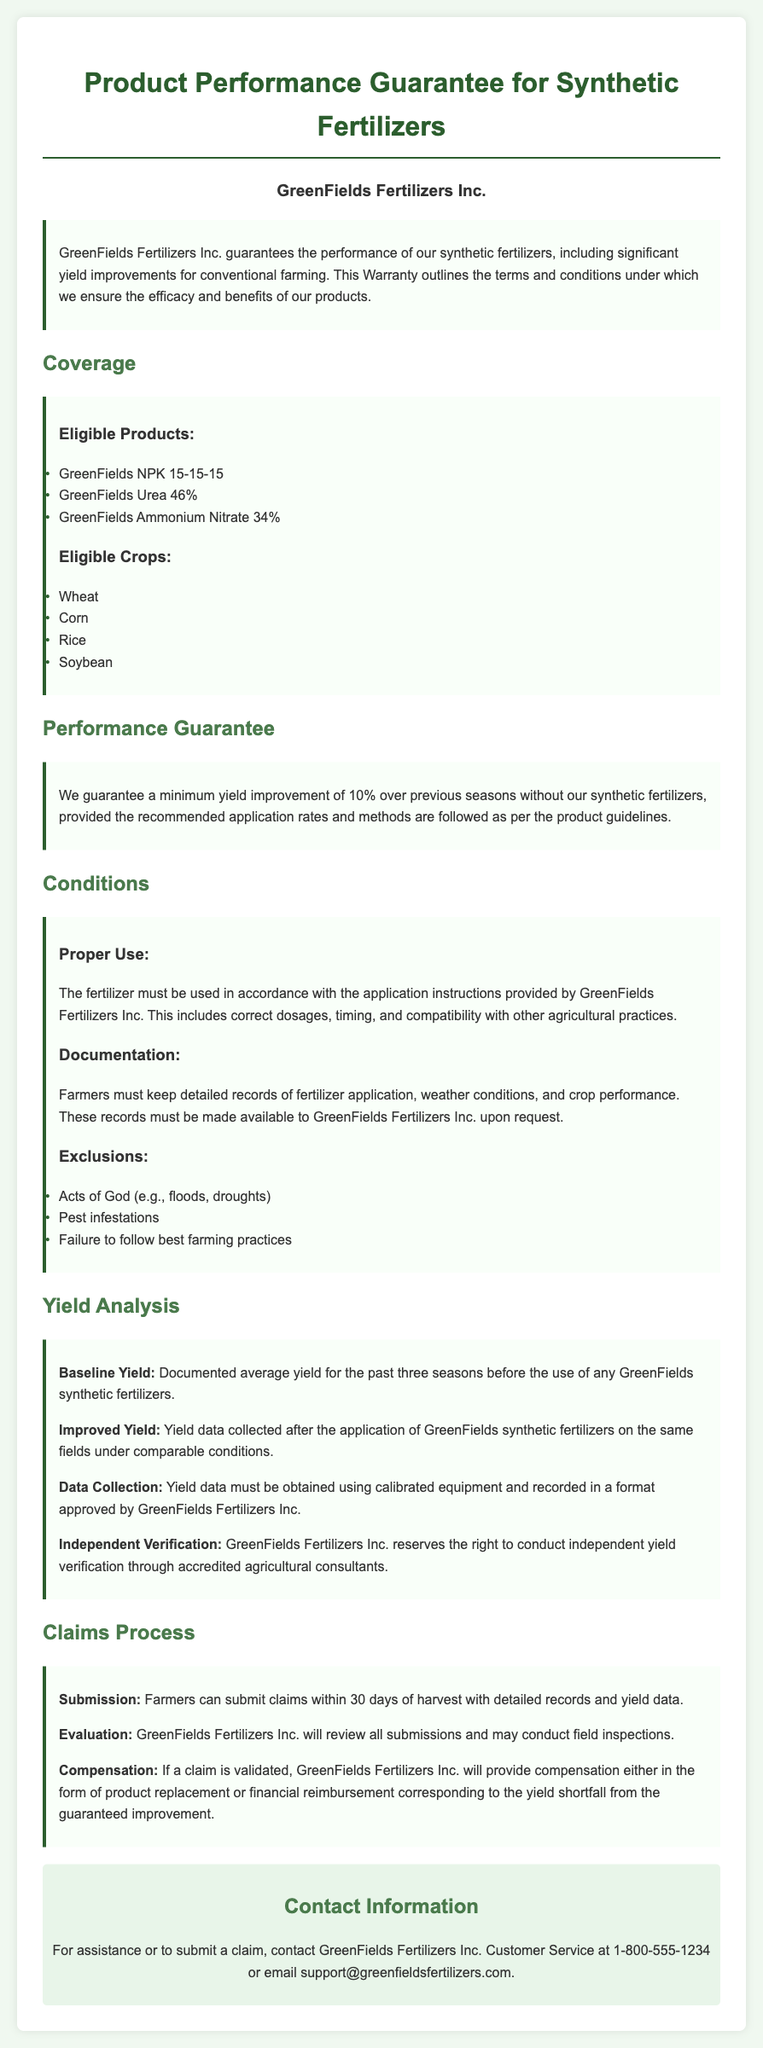What is the minimum yield improvement guaranteed? The document states that there is a guaranteed minimum yield improvement of 10% over previous seasons.
Answer: 10% Which crops are eligible for the performance guarantee? The document lists eligible crops including Wheat, Corn, Rice, and Soybean.
Answer: Wheat, Corn, Rice, Soybean What must farmers keep to validate their claims? The document specifies that farmers must keep detailed records of fertilizer application, weather conditions, and crop performance to validate their claims.
Answer: Detailed records What products are covered under the warranty? The document lists eligible products including GreenFields NPK 15-15-15, GreenFields Urea 46%, and GreenFields Ammonium Nitrate.
Answer: GreenFields NPK 15-15-15, GreenFields Urea 46%, GreenFields Ammonium Nitrate What is the claims submission period after harvest? The document states that farmers can submit claims within 30 days of harvest.
Answer: 30 days What type of verification does GreenFields reserve the right to conduct? The document mentions that GreenFields may conduct independent yield verification through accredited agricultural consultants.
Answer: Independent yield verification What conditions must be followed for the performance guarantee to be valid? The warranty states that the fertilizer must be used according to the application instructions provided by GreenFields Fertilizers Inc.
Answer: Application instructions What is the consequence of validated claims? The document states that if a claim is validated, GreenFields will provide compensation in the form of product replacement or financial reimbursement corresponding to the yield shortfall.
Answer: Compensation 